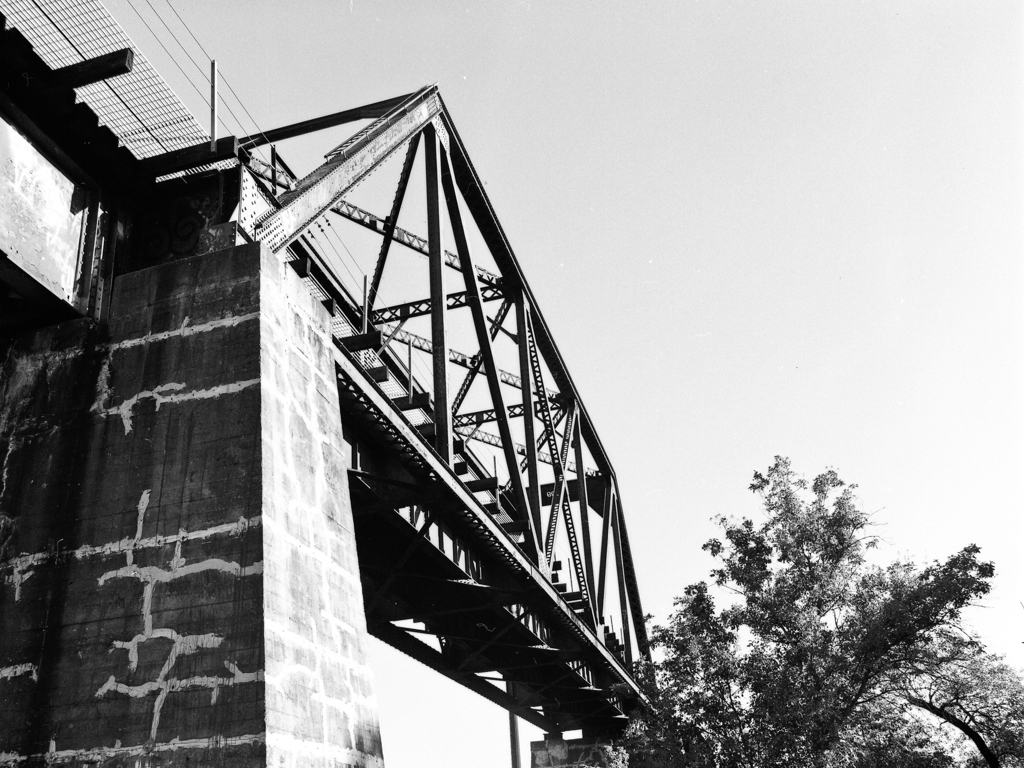Can you tell me something about the history or significance of this bridge? This image features a truss bridge, a common type of structure used for railway and road crossings. The truss design provides strength and durability. While I don't have specifics on this particular bridge's history, structures like this are usually significant due to their engineering design and the role they play in transportation and commerce, often becoming landmarks in their local areas. 